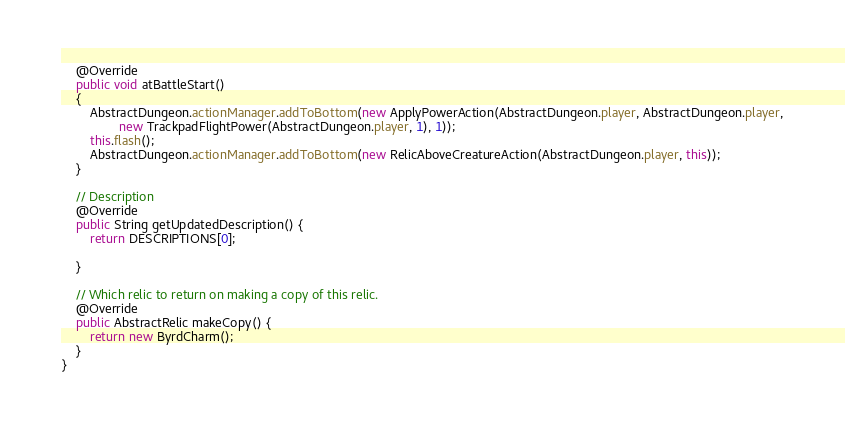Convert code to text. <code><loc_0><loc_0><loc_500><loc_500><_Java_>    @Override
    public void atBattleStart()
    {
        AbstractDungeon.actionManager.addToBottom(new ApplyPowerAction(AbstractDungeon.player, AbstractDungeon.player,
                new TrackpadFlightPower(AbstractDungeon.player, 1), 1));
        this.flash();
        AbstractDungeon.actionManager.addToBottom(new RelicAboveCreatureAction(AbstractDungeon.player, this));
    }

    // Description
    @Override
    public String getUpdatedDescription() {
        return DESCRIPTIONS[0];

    }

    // Which relic to return on making a copy of this relic.
    @Override
    public AbstractRelic makeCopy() {
        return new ByrdCharm();
    }
}
</code> 